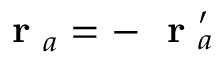<formula> <loc_0><loc_0><loc_500><loc_500>r _ { a } = - r _ { a } ^ { \prime }</formula> 